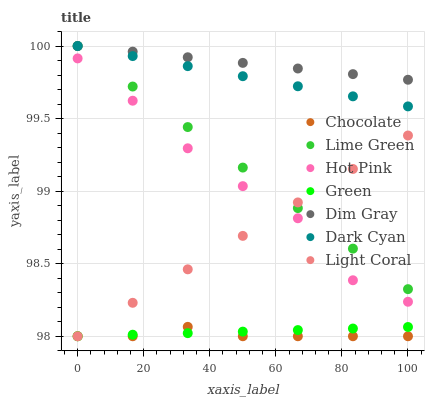Does Chocolate have the minimum area under the curve?
Answer yes or no. Yes. Does Dim Gray have the maximum area under the curve?
Answer yes or no. Yes. Does Hot Pink have the minimum area under the curve?
Answer yes or no. No. Does Hot Pink have the maximum area under the curve?
Answer yes or no. No. Is Dim Gray the smoothest?
Answer yes or no. Yes. Is Hot Pink the roughest?
Answer yes or no. Yes. Is Chocolate the smoothest?
Answer yes or no. No. Is Chocolate the roughest?
Answer yes or no. No. Does Chocolate have the lowest value?
Answer yes or no. Yes. Does Hot Pink have the lowest value?
Answer yes or no. No. Does Lime Green have the highest value?
Answer yes or no. Yes. Does Hot Pink have the highest value?
Answer yes or no. No. Is Hot Pink less than Dark Cyan?
Answer yes or no. Yes. Is Dark Cyan greater than Light Coral?
Answer yes or no. Yes. Does Dim Gray intersect Lime Green?
Answer yes or no. Yes. Is Dim Gray less than Lime Green?
Answer yes or no. No. Is Dim Gray greater than Lime Green?
Answer yes or no. No. Does Hot Pink intersect Dark Cyan?
Answer yes or no. No. 